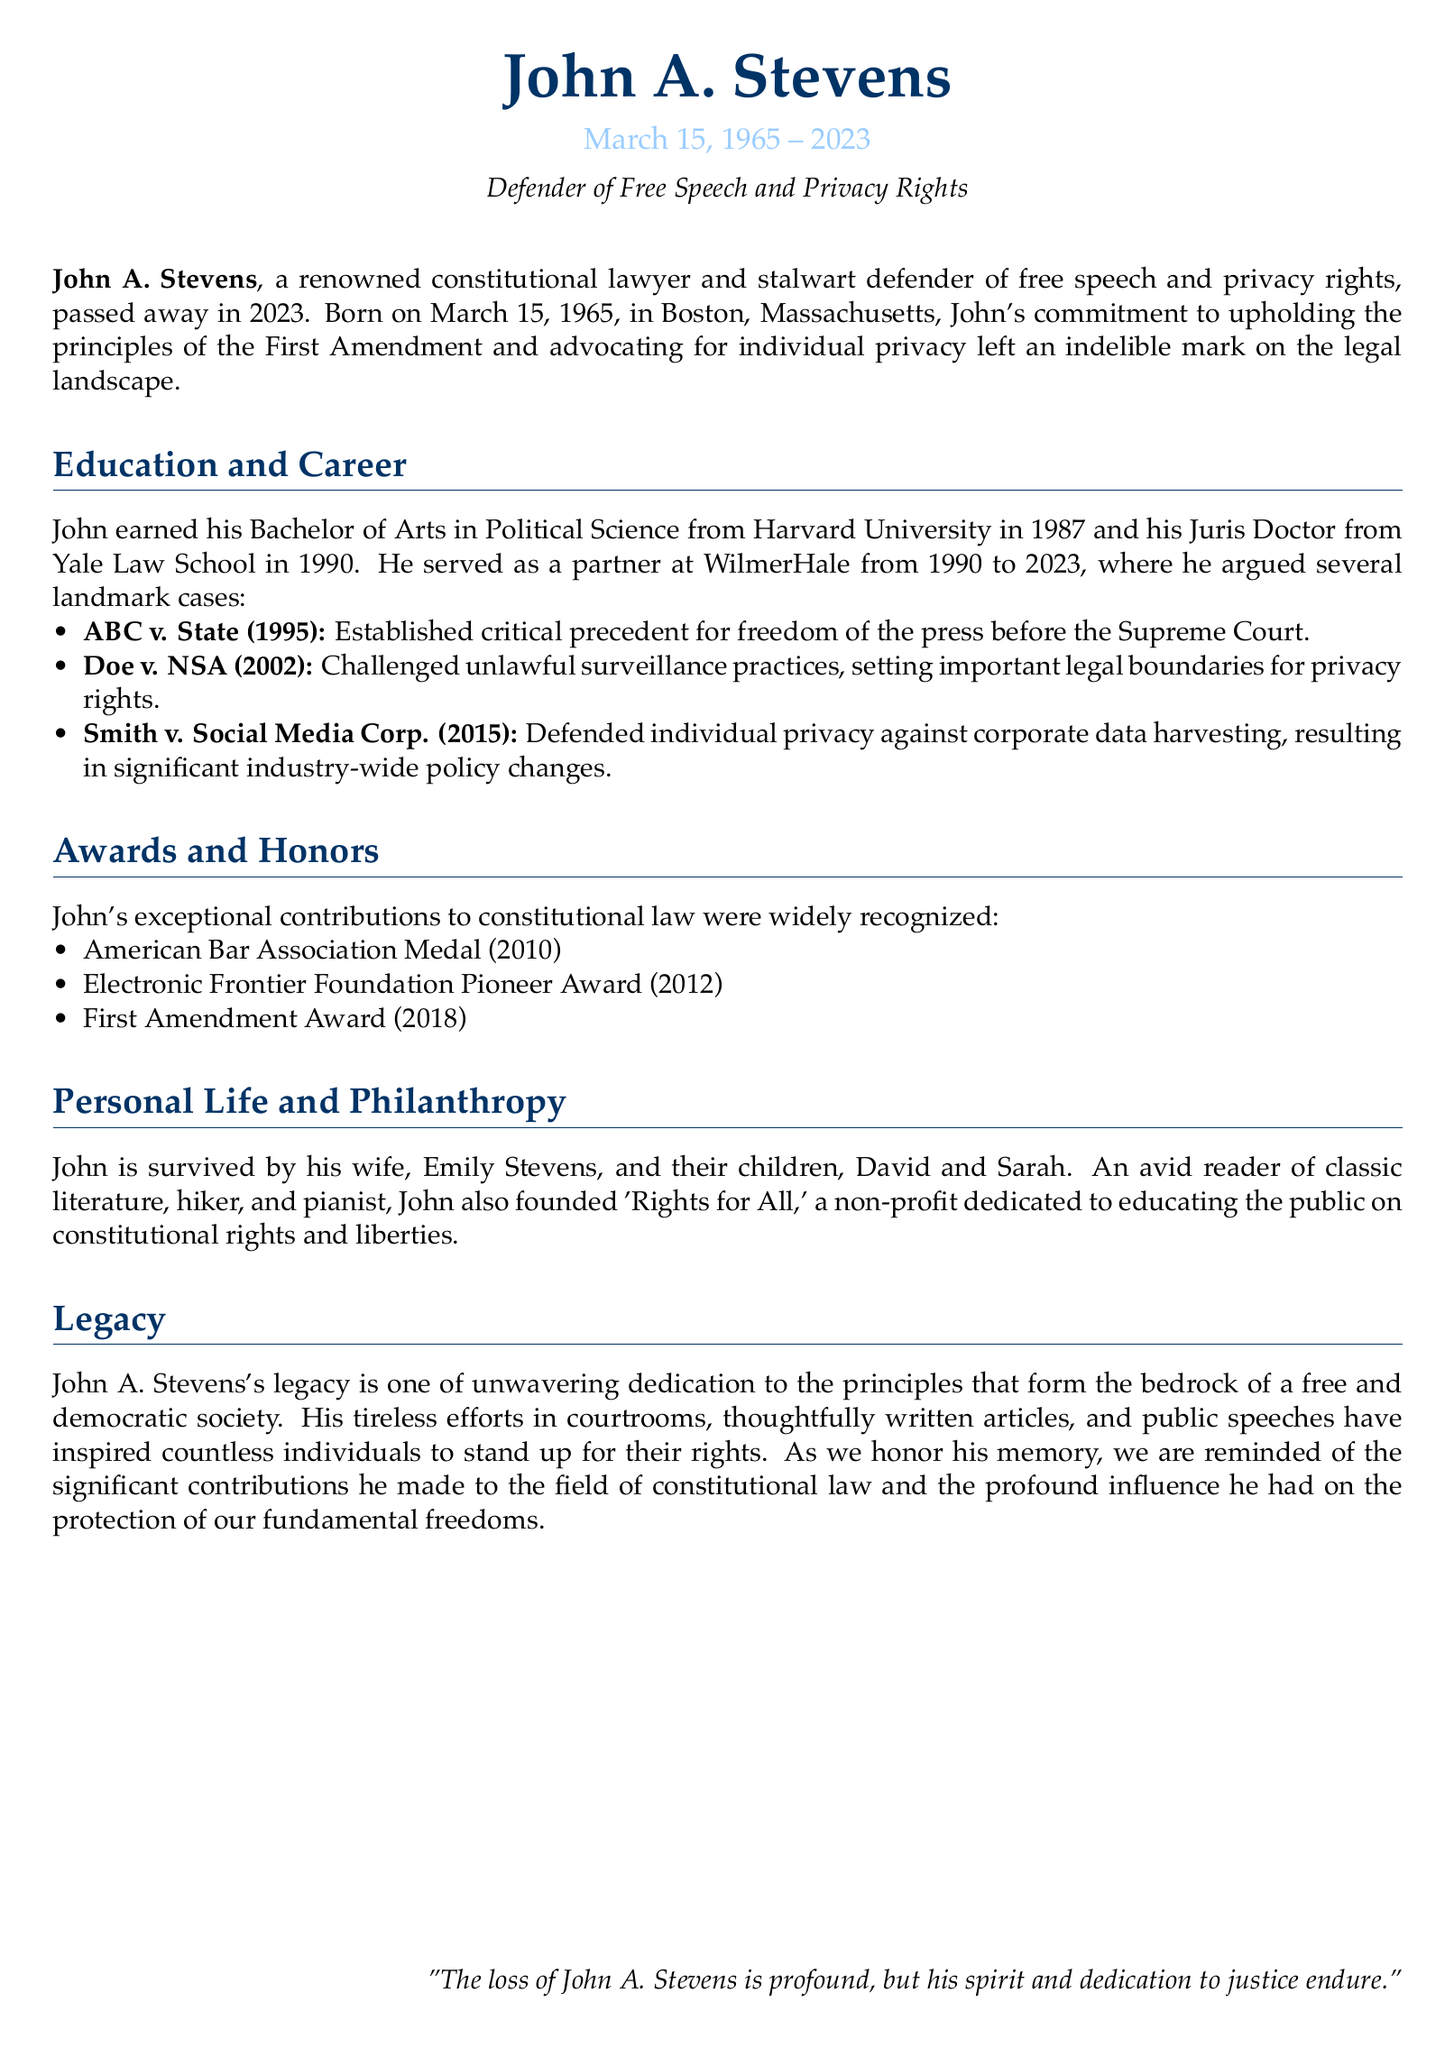What was John A. Stevens' birthdate? The birthdate is explicitly mentioned in the document as March 15, 1965.
Answer: March 15, 1965 Which organization awarded John the First Amendment Award? The document lists the First Amendment Award among other recognitions but does not specify the awarding organization. However, it is a known award typically given by organizations concerned with free speech.
Answer: Not specified In which year did John A. Stevens pass away? The document states he passed away in 2023.
Answer: 2023 What law school did John attend? The document notes that he earned his Juris Doctor from Yale Law School.
Answer: Yale Law School What was the case that established critical precedent for freedom of the press? The case mentioned for establishing critical precedent for freedom of the press is ABC v. State.
Answer: ABC v. State How many children did John A. Stevens have? The document mentions that he is survived by two children, David and Sarah.
Answer: Two What non-profit organization did John found? The document states he founded 'Rights for All.'
Answer: Rights for All What was John's primary area of legal defense? The document highlights his work defending free speech and privacy rights.
Answer: Free speech and privacy rights 